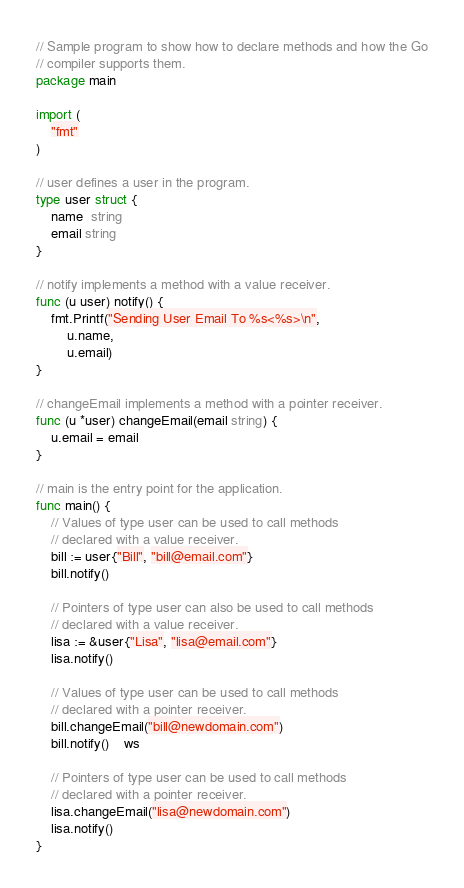<code> <loc_0><loc_0><loc_500><loc_500><_Go_>// Sample program to show how to declare methods and how the Go
// compiler supports them.
package main

import (
	"fmt"
)

// user defines a user in the program.
type user struct {
	name  string
	email string
}

// notify implements a method with a value receiver.
func (u user) notify() {
	fmt.Printf("Sending User Email To %s<%s>\n",
		u.name,
		u.email)
}

// changeEmail implements a method with a pointer receiver.
func (u *user) changeEmail(email string) {
	u.email = email
}

// main is the entry point for the application.
func main() {
	// Values of type user can be used to call methods
	// declared with a value receiver.
	bill := user{"Bill", "bill@email.com"}
	bill.notify()

	// Pointers of type user can also be used to call methods
	// declared with a value receiver.
	lisa := &user{"Lisa", "lisa@email.com"}
	lisa.notify()

	// Values of type user can be used to call methods
	// declared with a pointer receiver.
	bill.changeEmail("bill@newdomain.com")
	bill.notify()	ws

	// Pointers of type user can be used to call methods
	// declared with a pointer receiver.
	lisa.changeEmail("lisa@newdomain.com")
	lisa.notify()
}
</code> 